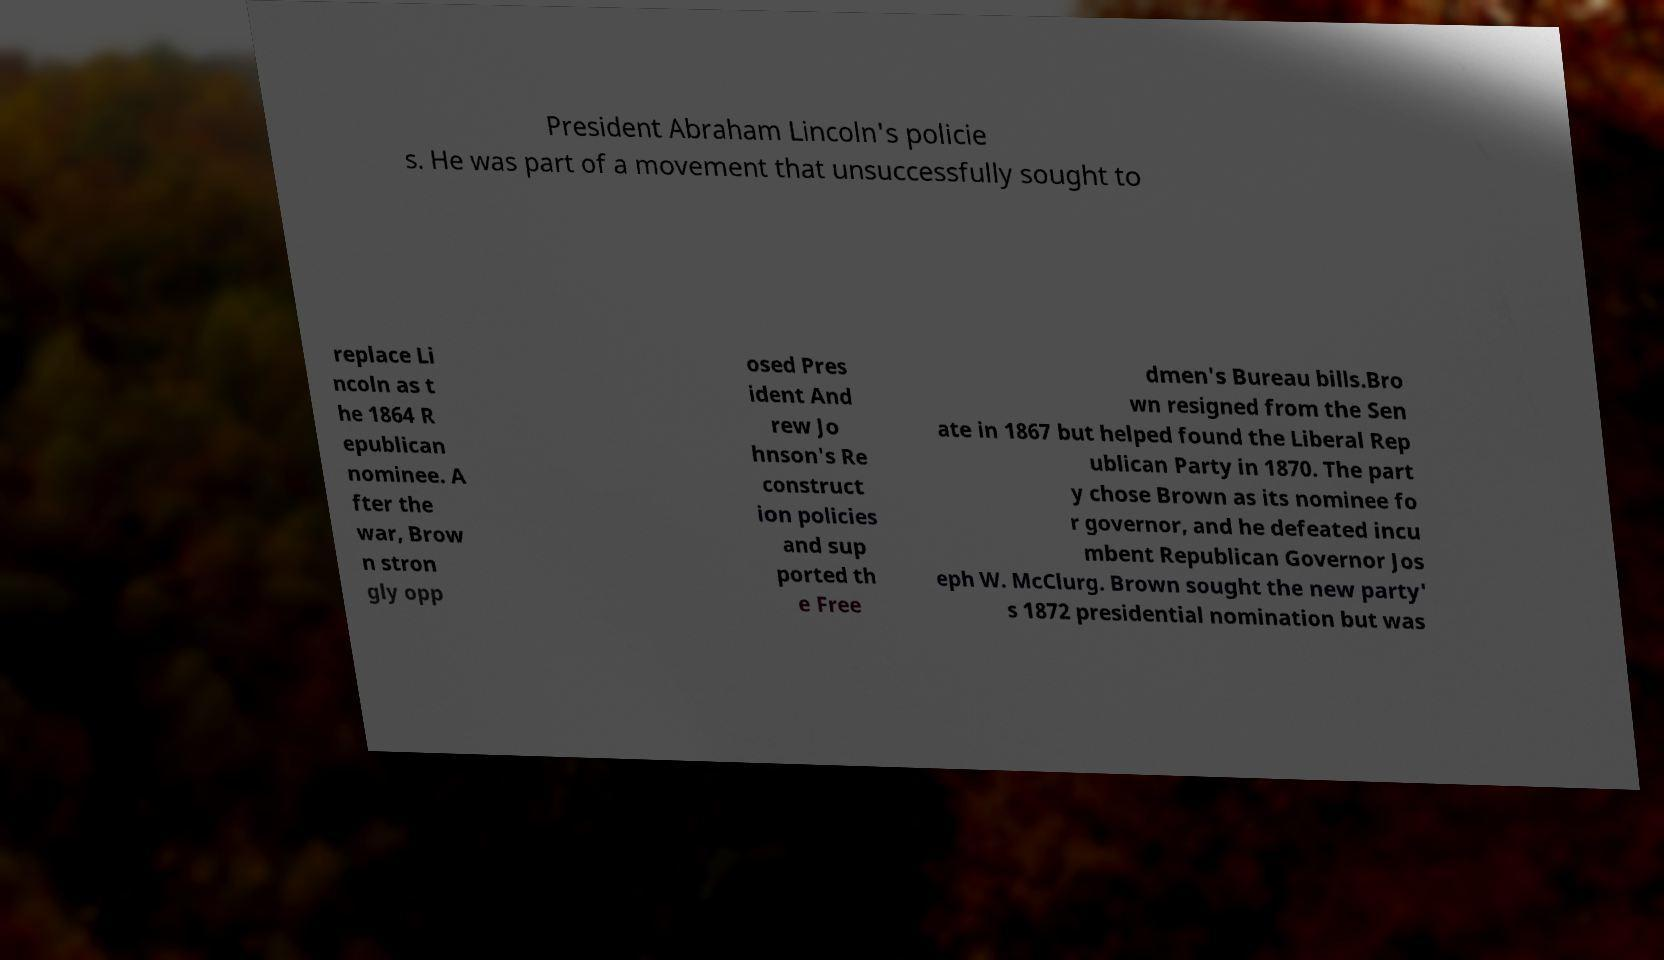Please identify and transcribe the text found in this image. President Abraham Lincoln's policie s. He was part of a movement that unsuccessfully sought to replace Li ncoln as t he 1864 R epublican nominee. A fter the war, Brow n stron gly opp osed Pres ident And rew Jo hnson's Re construct ion policies and sup ported th e Free dmen's Bureau bills.Bro wn resigned from the Sen ate in 1867 but helped found the Liberal Rep ublican Party in 1870. The part y chose Brown as its nominee fo r governor, and he defeated incu mbent Republican Governor Jos eph W. McClurg. Brown sought the new party' s 1872 presidential nomination but was 